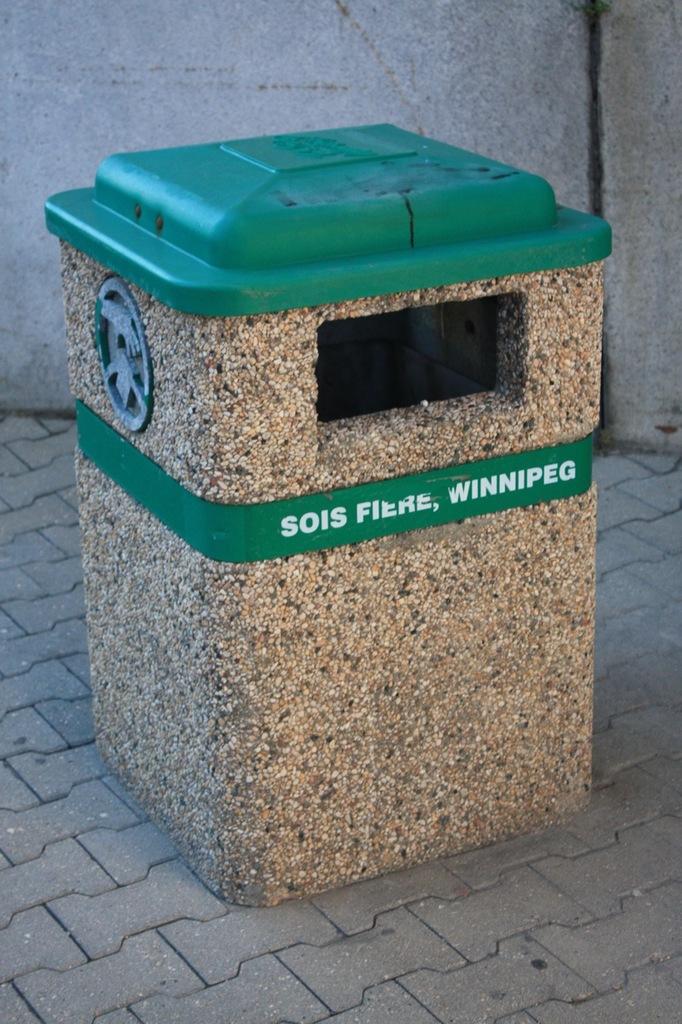What city is this from?
Offer a terse response. Winnipeg. What city name is on the trash can?
Your answer should be compact. Winnipeg. 